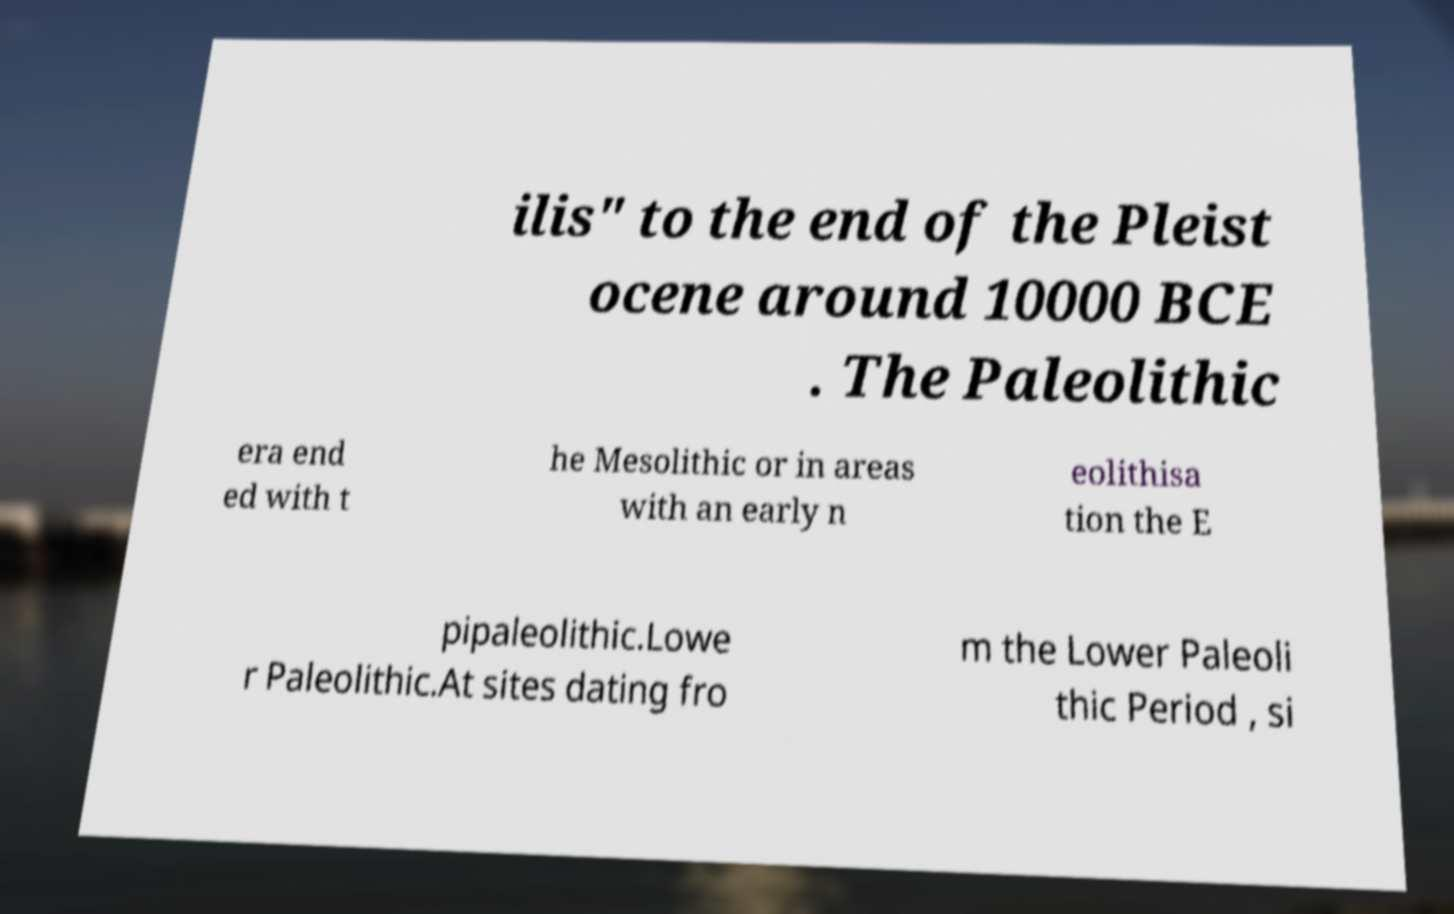For documentation purposes, I need the text within this image transcribed. Could you provide that? ilis" to the end of the Pleist ocene around 10000 BCE . The Paleolithic era end ed with t he Mesolithic or in areas with an early n eolithisa tion the E pipaleolithic.Lowe r Paleolithic.At sites dating fro m the Lower Paleoli thic Period , si 